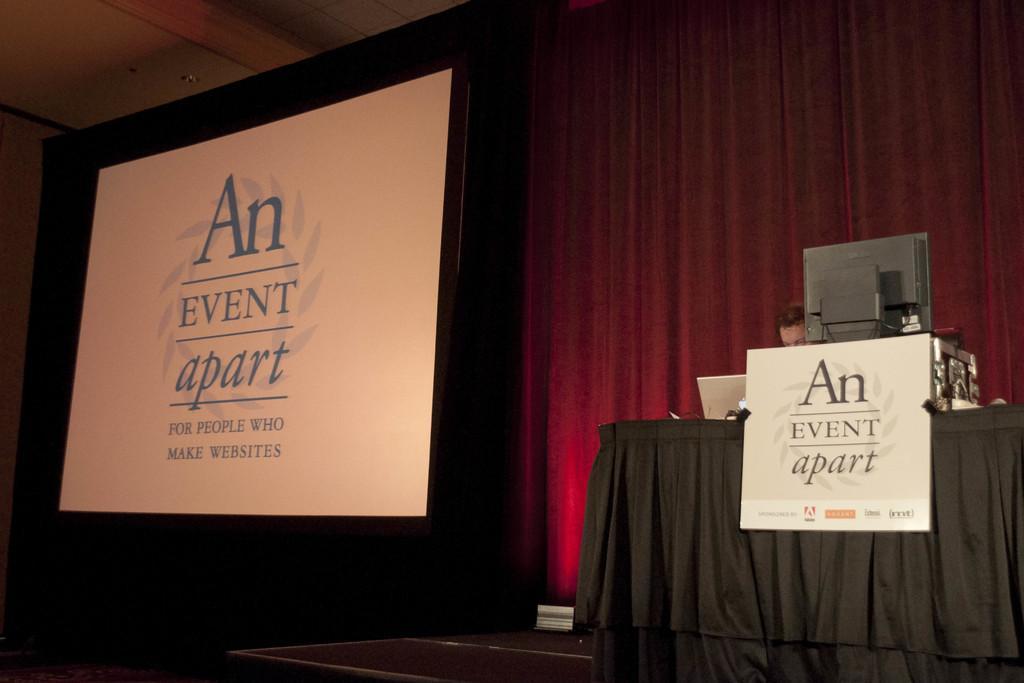Describe this image in one or two sentences. At the bottom of this image there is a stage. On the right side there is a table which is covered with a cloth and a board is attached to the table. On the board, I can see some text. Behind a monitor, laptop and some other objects are placed on this table and also there is a person. On the left side there is a screen on which I can see some text. In the background there is a curtain. 